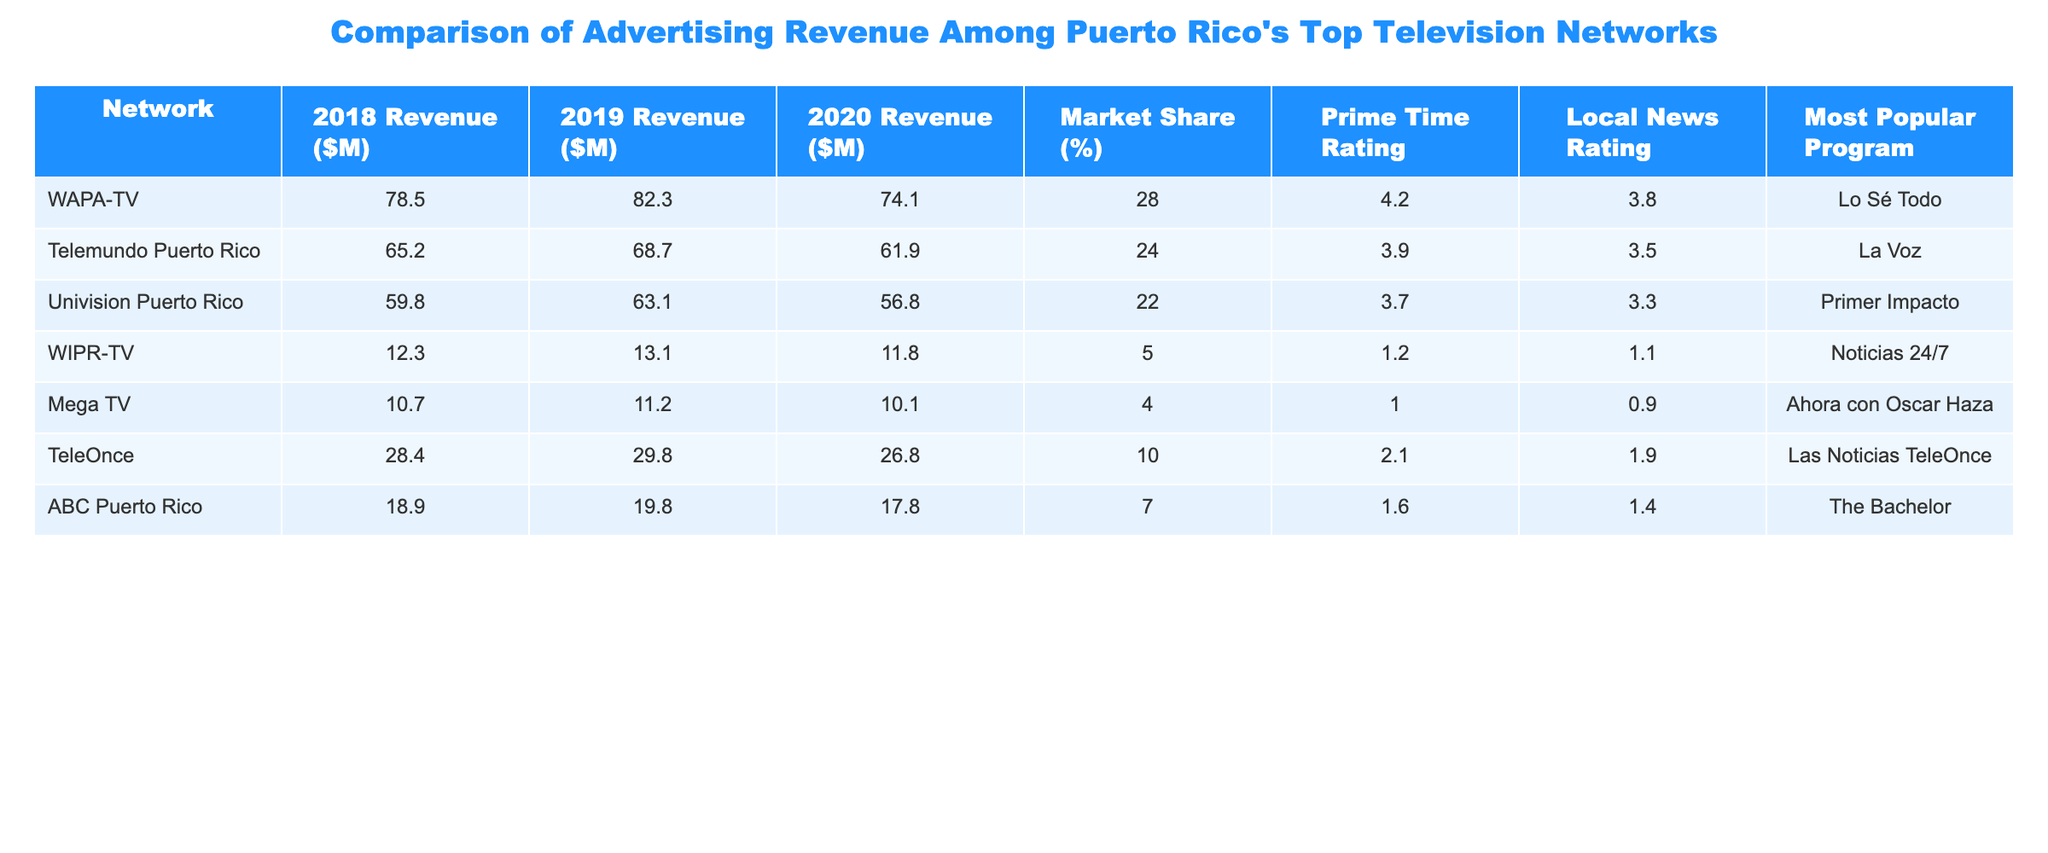What was the advertising revenue of WAPA-TV in 2020? WAPA-TV's revenue for 2020 is directly listed in the table as 74.1 million dollars.
Answer: 74.1 million dollars Which network had the highest market share in 2020? The table shows market share for each network; WAPA-TV had a market share of 28%, which is the highest among the listed networks in 2020.
Answer: WAPA-TV What is the difference in advertising revenue for Telemundo Puerto Rico from 2018 to 2020? Telemundo Puerto Rico's revenue in 2018 was 65.2 million dollars and in 2020 was 61.9 million dollars. The difference is 65.2 - 61.9 = 3.3 million dollars.
Answer: 3.3 million dollars Did any network have a local news rating above 3.5 in 2020? By examining the local news ratings in the table, WAPA-TV had a rating of 3.8 in 2020, which is above 3.5.
Answer: Yes Which network saw the largest decrease in advertising revenue from 2019 to 2020? To find this, we calculate the decrease for each network: WAPA-TV (82.3 - 74.1 = 8.2), Telemundo (68.7 - 61.9 = 6.8), Univision (63.1 - 56.8 = 6.3), etc. The largest decrease is 8.2 million dollars for WAPA-TV.
Answer: WAPA-TV What was the prime time rating of Mega TV in 2019? The prime time rating for Mega TV in 2019 is 1.0 according to the table provided.
Answer: 1.0 What is the average revenue for all networks in 2019? To find the average revenue, add the revenues for 2019: (82.3 + 68.7 + 63.1 + 13.1 + 11.2 + 29.8 + 19.8) = 288.2 million dollars. Dividing by 7 networks gives an average of 288.2 / 7 ≈ 41.17 million dollars.
Answer: 41.17 million dollars Did TeleOnce have a more popular program than WAPA-TV in 2020? By comparing the most popular programs in the table, "Lo Sé Todo" from WAPA-TV is not directly comparable to "Las Noticias TeleOnce" from TeleOnce, but WAPA-TV's program has a higher viewership rating. Thus, TeleOnce did not outshine WAPA-TV in popularity based on the provided ratings.
Answer: No What was the total advertising revenue for all networks in 2018? Summing the revenues for 2018 gives: (78.5 + 65.2 + 59.8 + 12.3 + 10.7 + 28.4 + 18.9) = 273.8 million dollars for all networks combined in 2018.
Answer: 273.8 million dollars 